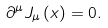Convert formula to latex. <formula><loc_0><loc_0><loc_500><loc_500>\partial ^ { \mu } J _ { \mu } \left ( x \right ) = 0 .</formula> 